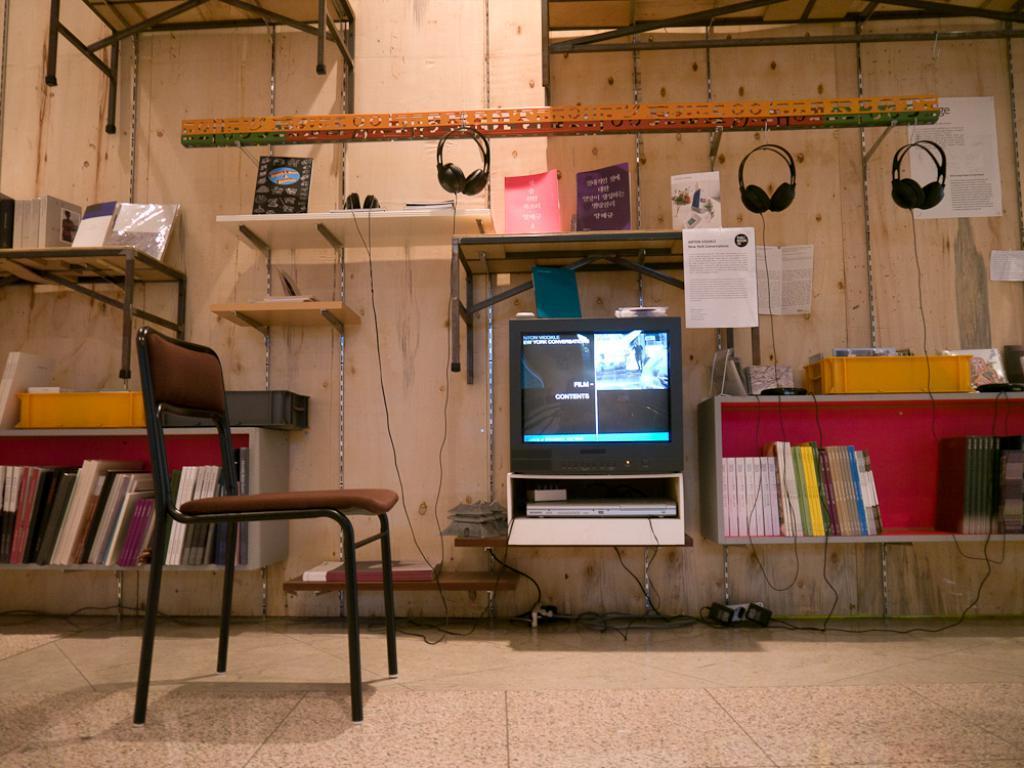Please provide a concise description of this image. This is a chair. I think this is a television with the display. This looks like a DVD player. I can see the books, which are placed in the racks. These are the headsets hanging. This looks like a wall. I can see the papers, which are attached to the wall. This looks like a tray with few objects in it. I can see the cables lying on the floor. 